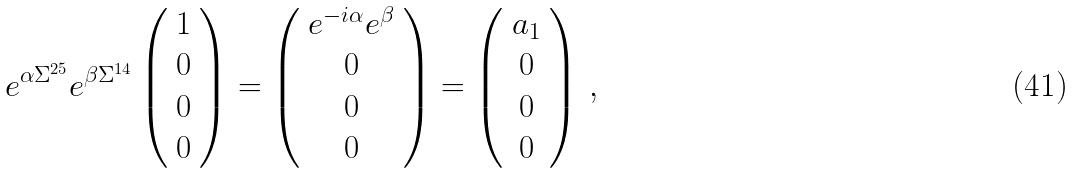Convert formula to latex. <formula><loc_0><loc_0><loc_500><loc_500>e ^ { \alpha \Sigma ^ { 2 5 } } e ^ { \beta \Sigma ^ { 1 4 } } \left ( \begin{array} { c } 1 \\ 0 \\ 0 \\ 0 \end{array} \right ) = \left ( \begin{array} { c } e ^ { - i \alpha } e ^ { \beta } \\ 0 \\ 0 \\ 0 \end{array} \right ) = \left ( \begin{array} { c } a _ { 1 } \\ 0 \\ 0 \\ 0 \end{array} \right ) \, ,</formula> 